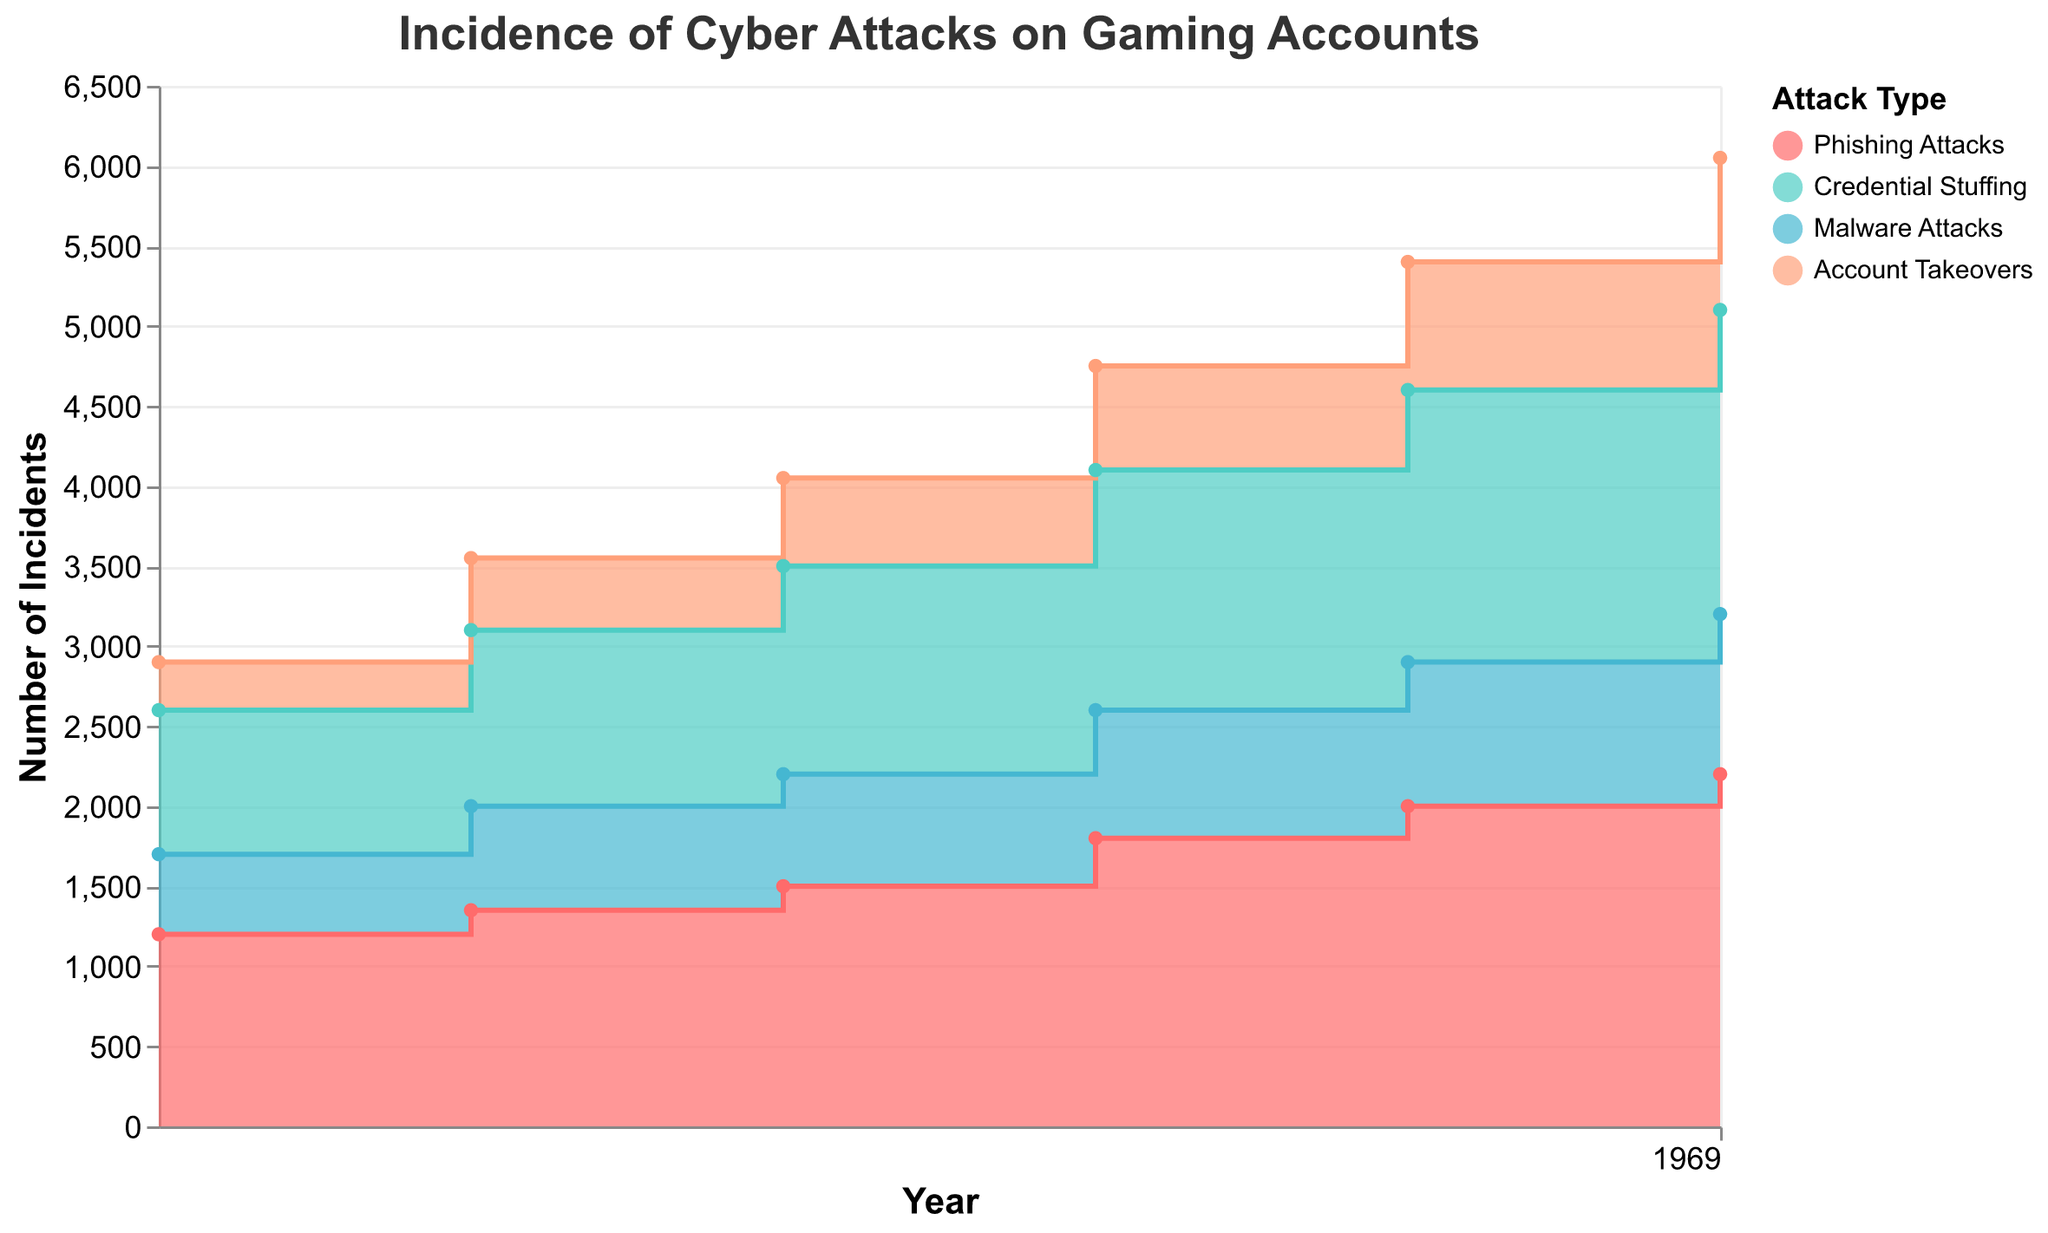What is the title of the figure? The title is usually found at the top of the figure and provides a summary of what the chart is depicting.
Answer: Incidence of Cyber Attacks on Gaming Accounts How many types of cyber attacks are shown in the chart? In the legend, you can see the distinct categories of cyber attacks represented.
Answer: Four Which type of cyber attack had the highest number of incidents in 2023? By looking at the highest point on the graph for the year 2023 and identifying the color associated with it, we can determine the type of attack.
Answer: Phishing Attacks Between 2018 and 2023, which type of cyber attack showed the greatest increase in incidents? To determine the greatest increase, calculate the difference in the number of incidents for each type of attack between 2018 and 2023, then compare the differences.
Answer: Phishing Attacks What is the total number of incidents for all types of attacks in the year 2021? Sum the values of all the types of attacks for the year 2021 using the data provided in the chart.
Answer: 4750 Which type of attack had the smallest growth in incidents from 2018 to 2022? Calculate the increase for each type of attack from 2018 to 2022, then identify the smallest value.
Answer: Account Takeovers What is the trend of Malware Attacks from 2018 to 2023? Analyzing the shape and direction of the area representing Malware Attacks over the years will show if it is increasing, decreasing, or stable.
Answer: Increasing In what year did Credential Stuffing surpass 1500 incidents? Identify the first year where the value for Credential Stuffing attacks is greater than 1500 in the chart.
Answer: 2021 How many years did Phishing Attacks have more incidents than Malware Attacks? For each year, compare the incidents of Phishing Attacks with Malware Attacks and count how many times Phishing Attacks are higher.
Answer: Six years Which two types of attacks had nearly the same number of incidents in 2020? Review the data points for each type of attack in 2020 and find the pair with the closest values.
Answer: Credential Stuffing and Phishing Attacks 